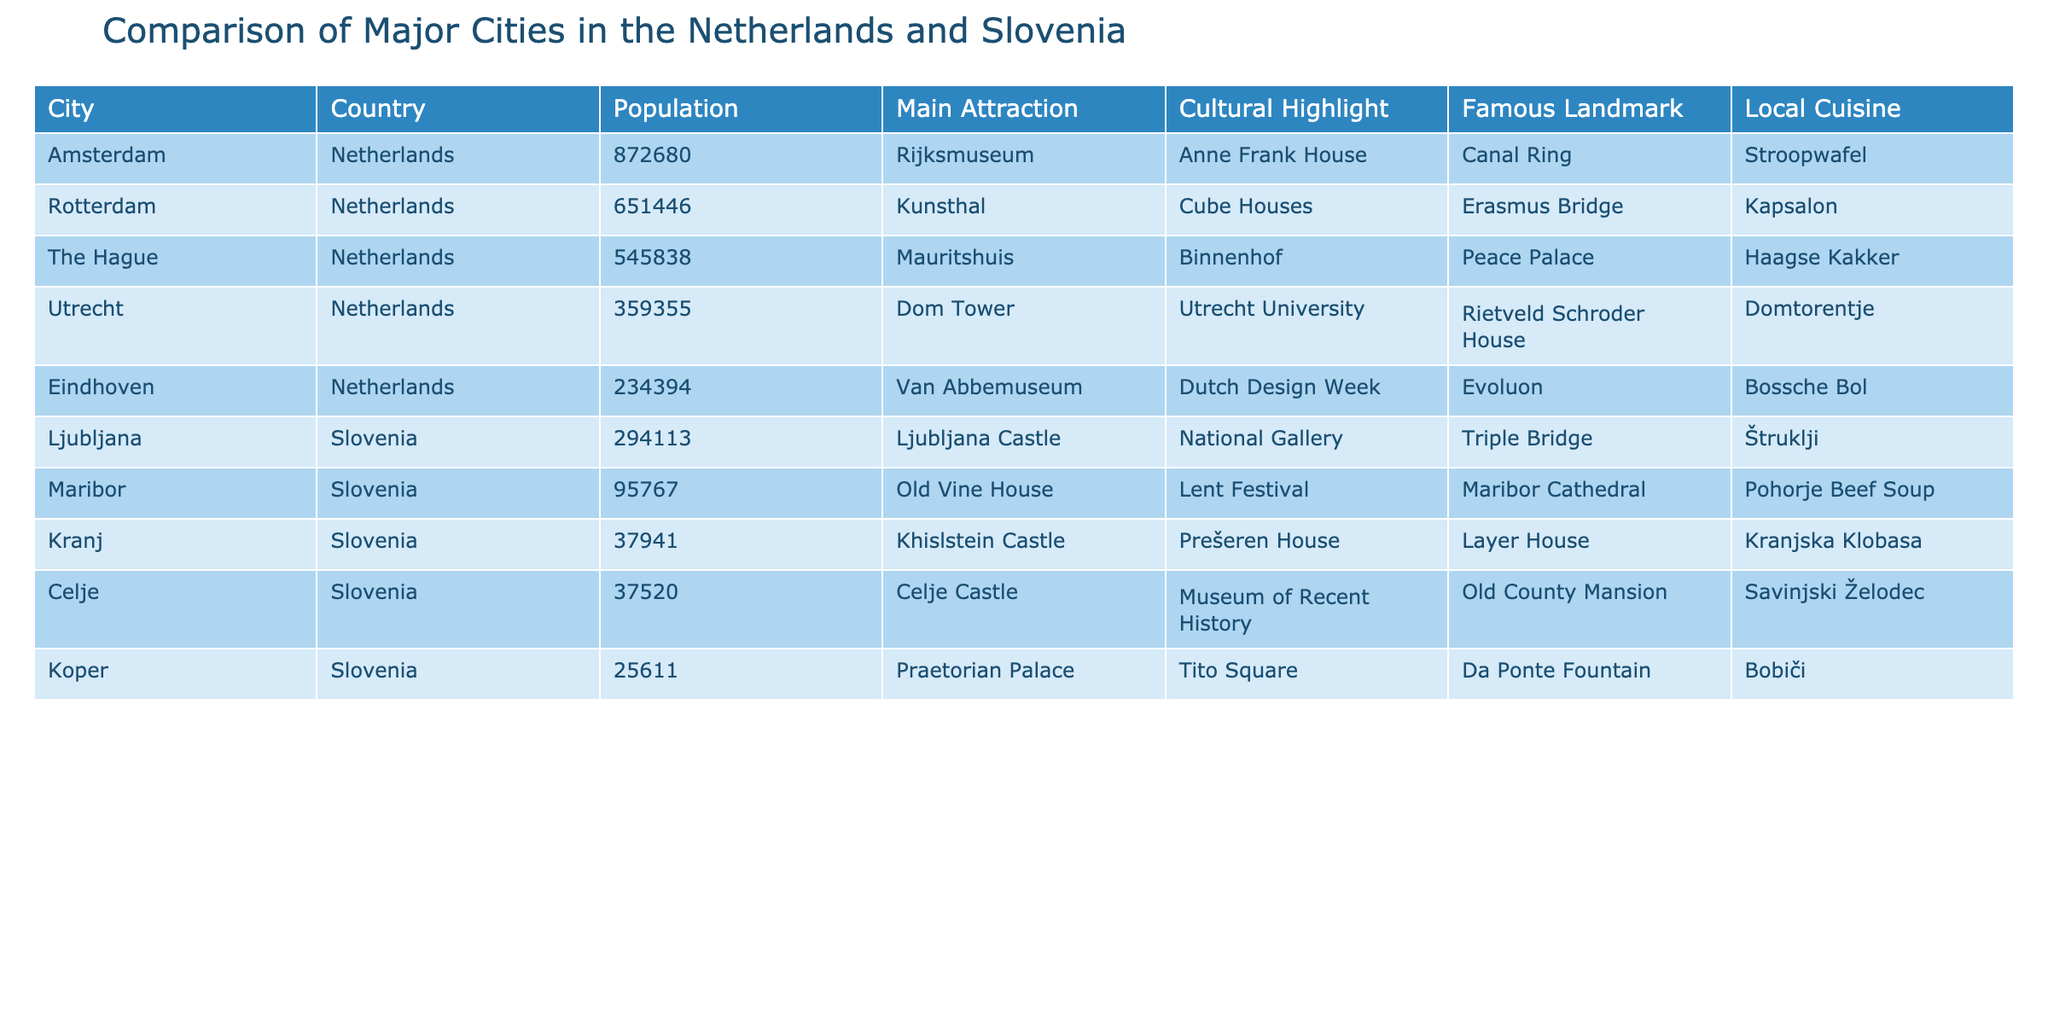What city in the Netherlands has the highest population? From the table, Amsterdam is listed with a population of 872680, which is the highest compared to other cities in the Netherlands.
Answer: Amsterdam Is Ljubljana the capital city of Slovenia? Yes, Ljubljana is noted in the table as the major city of Slovenia where the main attraction is Ljubljana Castle, and it serves as the capital city.
Answer: Yes What is the main attraction in Rotterdam? According to the table, the main attraction in Rotterdam is Kunsthal.
Answer: Kunsthal What are the populations of Maribor and Celje combined? To find the combined population of Maribor and Celje, we add their populations: Maribor (95767) + Celje (37520) = 133287.
Answer: 133287 Does the city of Utrecht have a famous landmark? Yes, the table lists the Domtorentje as the famous landmark of Utrecht.
Answer: Yes Which city has a larger population: Koper or Kranj? The table shows Koper with a population of 25611 and Kranj with 37941. Since 37941 > 25611, Kranj has a larger population.
Answer: Kranj What is the average population of the major cities listed in Slovenia? To calculate the average, sum the populations of Ljubljana (294113), Maribor (95767), Celje (37520), and Kranj (37941) to get 468541. There are 4 cities, so the average is 468541/4 = 117135.25.
Answer: 117135.25 Which attraction is shared by both the Netherlands and Slovenia table? The table doesn't indicate any shared attraction between the cities in the Netherlands and Slovenia; each city has its own unique attractions.
Answer: No In which city would you find the famous landmark Erasmus Bridge? The table indicates that the Erasmus Bridge is located in Rotterdam, Netherlands.
Answer: Rotterdam 